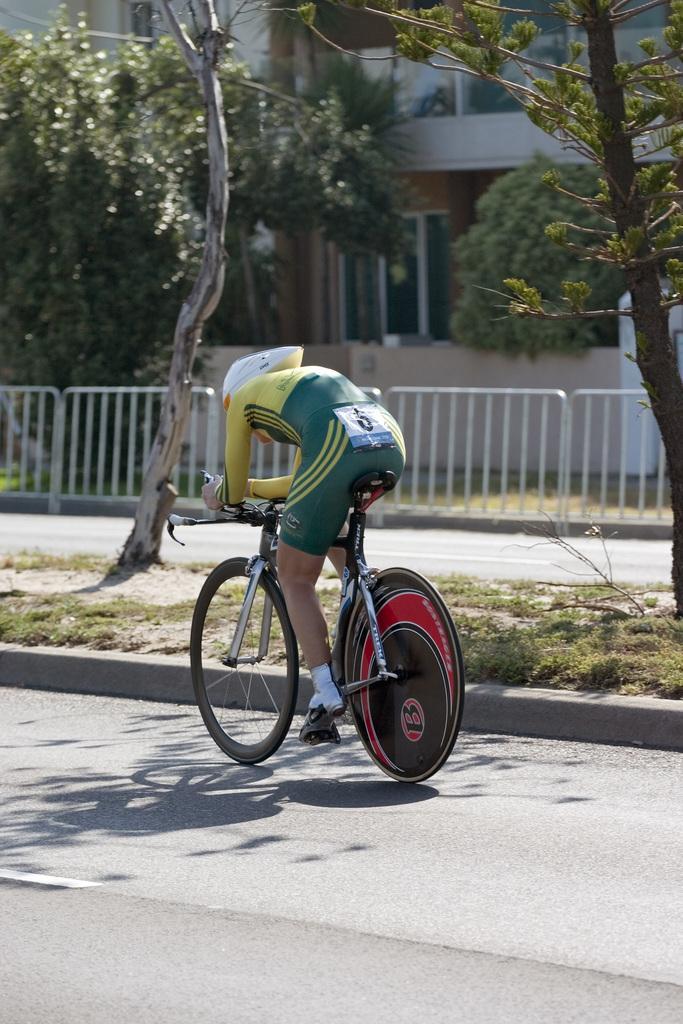Could you give a brief overview of what you see in this image? In this image I can see a person is riding the bicycle. Back I can see few trees, fencing, building and windows. 